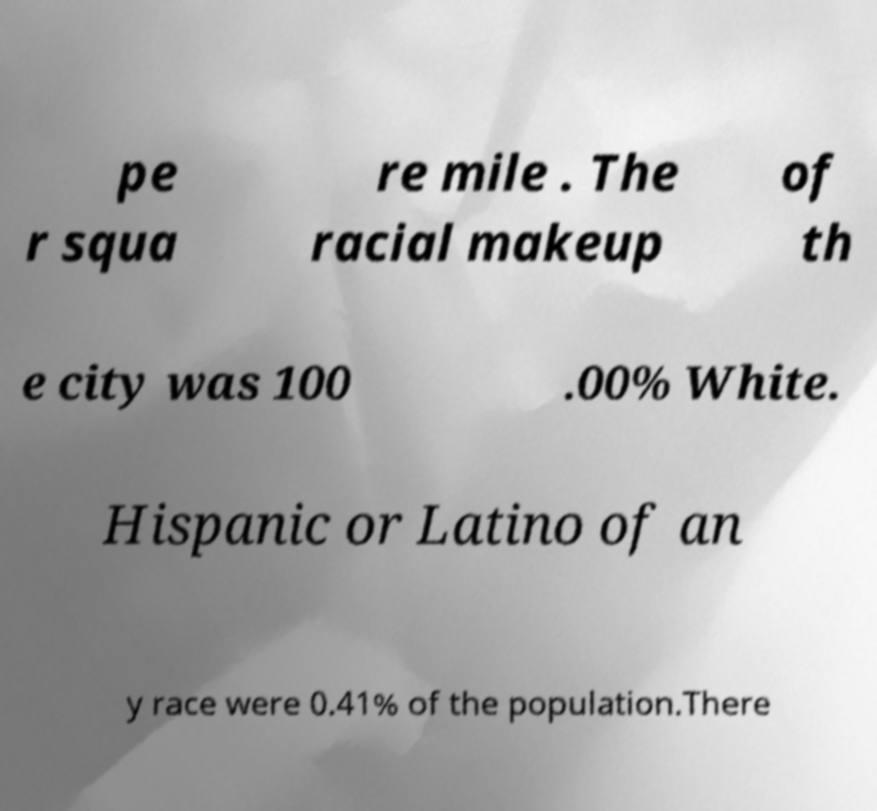For documentation purposes, I need the text within this image transcribed. Could you provide that? pe r squa re mile . The racial makeup of th e city was 100 .00% White. Hispanic or Latino of an y race were 0.41% of the population.There 